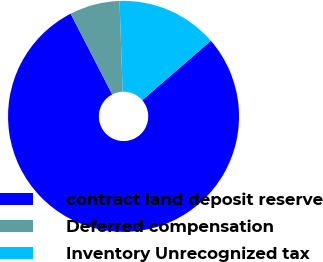<chart> <loc_0><loc_0><loc_500><loc_500><pie_chart><fcel>contract land deposit reserve<fcel>Deferred compensation<fcel>Inventory Unrecognized tax<nl><fcel>78.79%<fcel>7.02%<fcel>14.19%<nl></chart> 